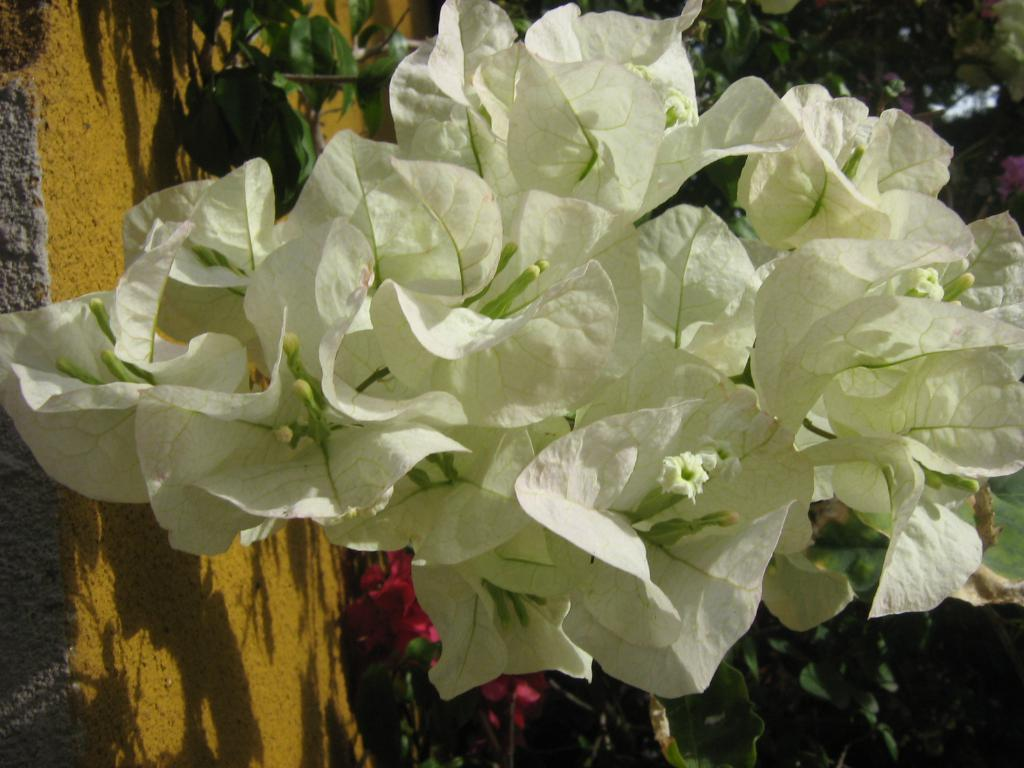What type of living organisms can be seen in the image? There are flowers and plants with leaves and flowers in the image. Can you describe the plants in the image? The plants in the image have leaves and flowers. What type of cheese is being used to make the scarecrow in the image? There is no scarecrow or cheese present in the image. What material is the copper plant made of in the image? There is no copper plant present in the image. 